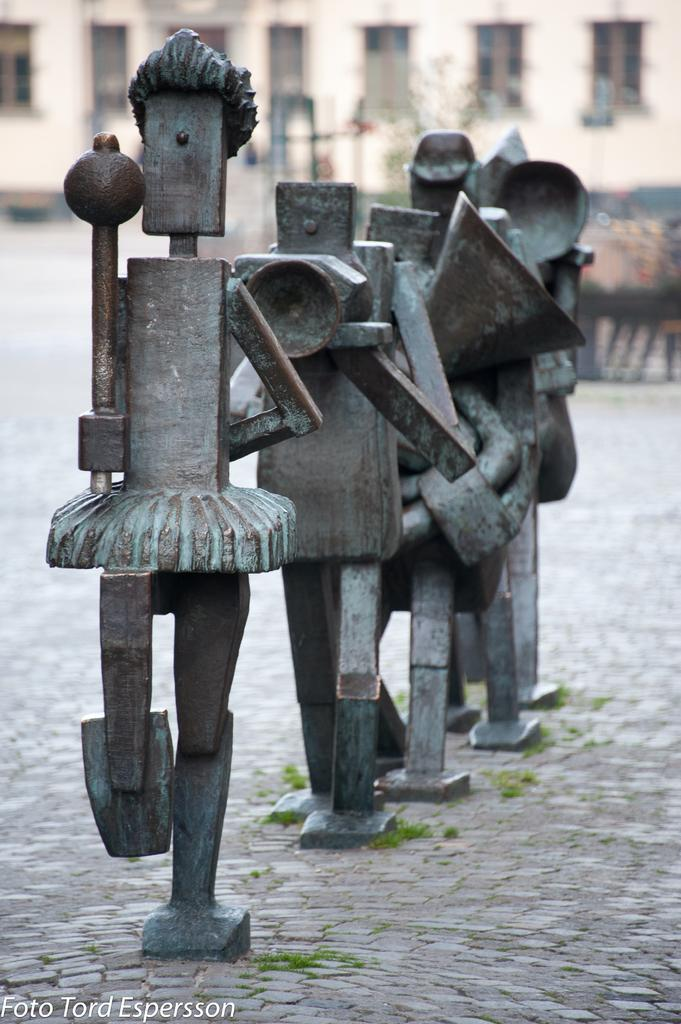What type of objects are in the foreground of the image? There are metal statues in the foreground of the image. Where are the metal statues located? The metal statues are on a pavement. What can be seen in the background of the image? There is a building in the background of the image. What type of stick is being used by the metal statues in the image? There is no stick present in the image; the metal statues are stationary. 